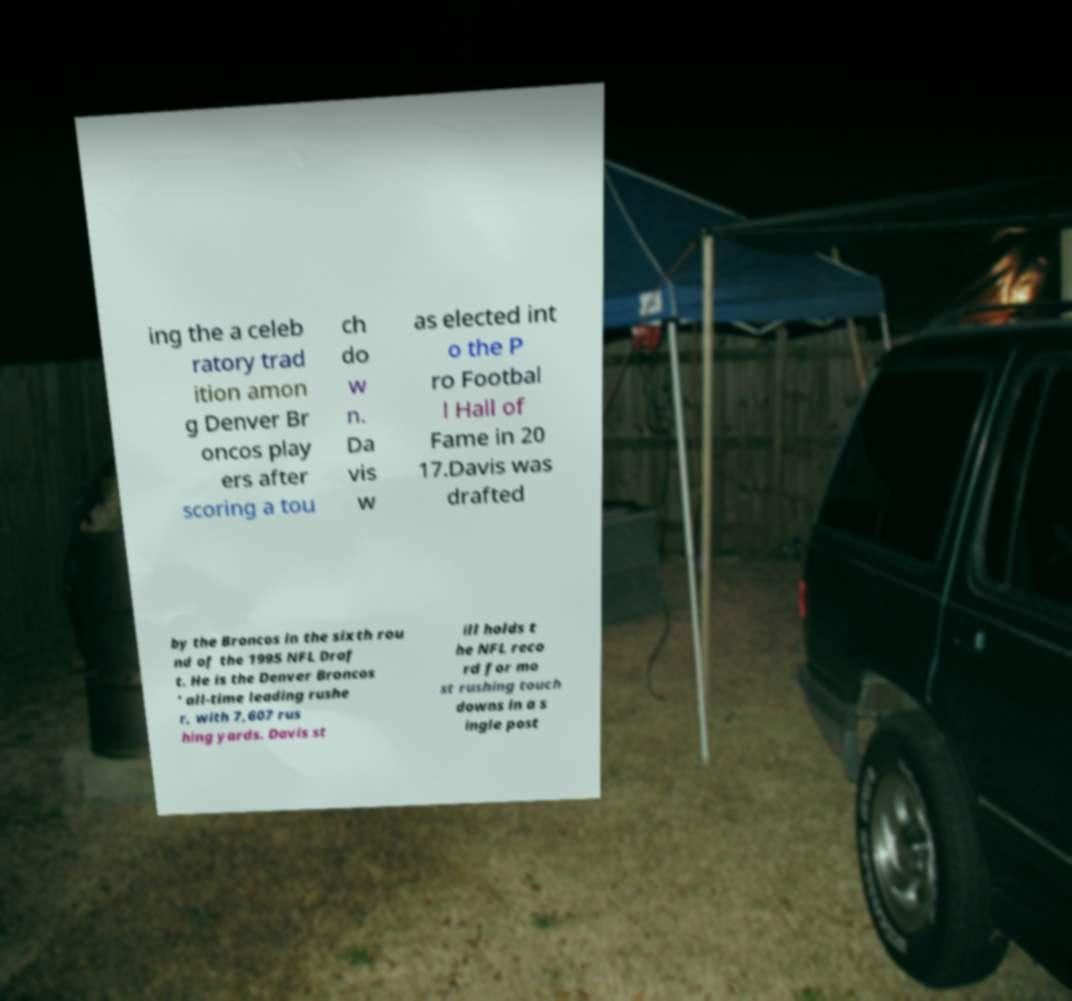Could you assist in decoding the text presented in this image and type it out clearly? ing the a celeb ratory trad ition amon g Denver Br oncos play ers after scoring a tou ch do w n. Da vis w as elected int o the P ro Footbal l Hall of Fame in 20 17.Davis was drafted by the Broncos in the sixth rou nd of the 1995 NFL Draf t. He is the Denver Broncos ' all-time leading rushe r, with 7,607 rus hing yards. Davis st ill holds t he NFL reco rd for mo st rushing touch downs in a s ingle post 